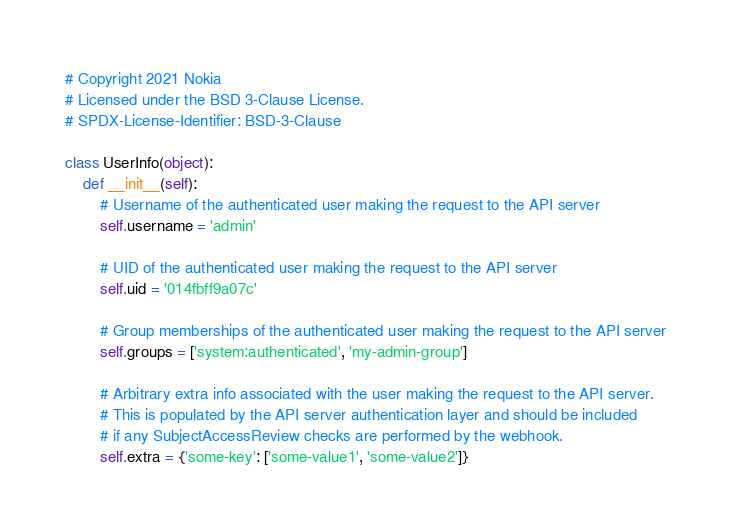Convert code to text. <code><loc_0><loc_0><loc_500><loc_500><_Python_># Copyright 2021 Nokia
# Licensed under the BSD 3-Clause License.
# SPDX-License-Identifier: BSD-3-Clause

class UserInfo(object):
    def __init__(self):
        # Username of the authenticated user making the request to the API server
        self.username = 'admin'

        # UID of the authenticated user making the request to the API server
        self.uid = '014fbff9a07c'

        # Group memberships of the authenticated user making the request to the API server
        self.groups = ['system:authenticated', 'my-admin-group']

        # Arbitrary extra info associated with the user making the request to the API server.
        # This is populated by the API server authentication layer and should be included
        # if any SubjectAccessReview checks are performed by the webhook.
        self.extra = {'some-key': ['some-value1', 'some-value2']}
</code> 